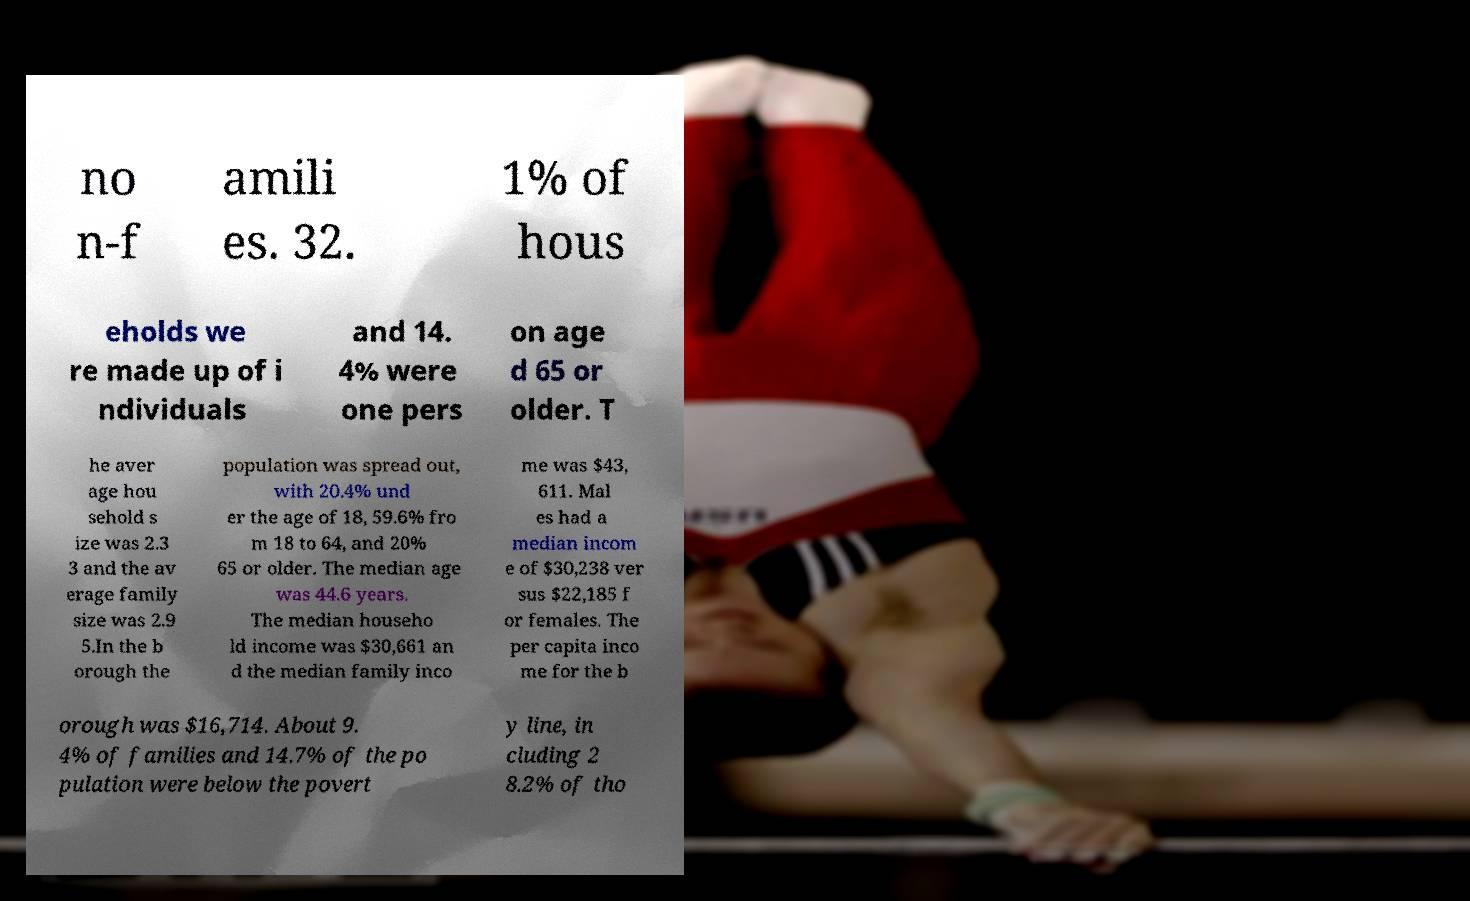I need the written content from this picture converted into text. Can you do that? no n-f amili es. 32. 1% of hous eholds we re made up of i ndividuals and 14. 4% were one pers on age d 65 or older. T he aver age hou sehold s ize was 2.3 3 and the av erage family size was 2.9 5.In the b orough the population was spread out, with 20.4% und er the age of 18, 59.6% fro m 18 to 64, and 20% 65 or older. The median age was 44.6 years. The median househo ld income was $30,661 an d the median family inco me was $43, 611. Mal es had a median incom e of $30,238 ver sus $22,185 f or females. The per capita inco me for the b orough was $16,714. About 9. 4% of families and 14.7% of the po pulation were below the povert y line, in cluding 2 8.2% of tho 